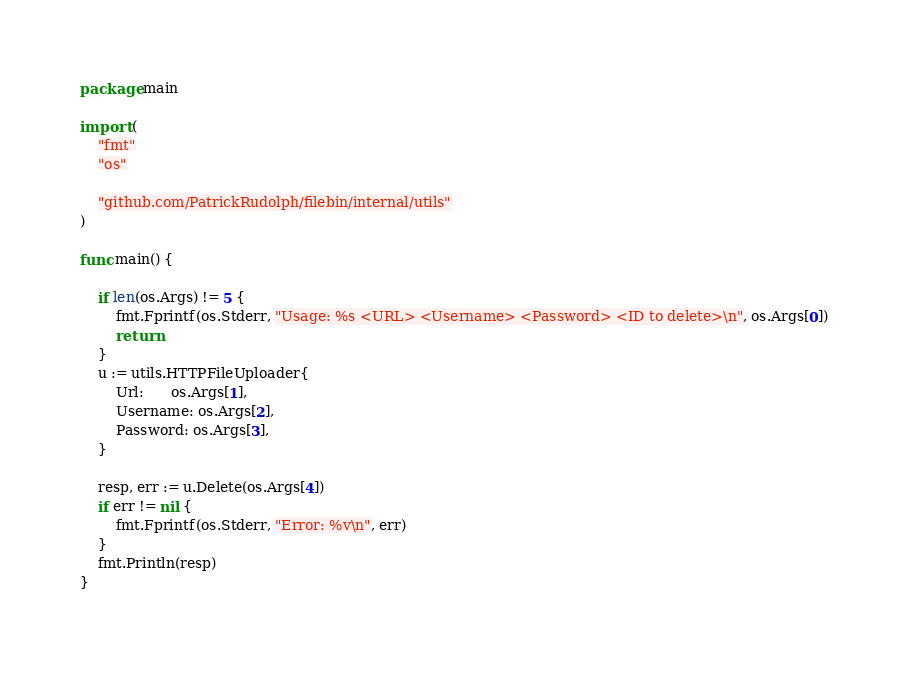Convert code to text. <code><loc_0><loc_0><loc_500><loc_500><_Go_>package main

import (
	"fmt"
	"os"

	"github.com/PatrickRudolph/filebin/internal/utils"
)

func main() {

	if len(os.Args) != 5 {
		fmt.Fprintf(os.Stderr, "Usage: %s <URL> <Username> <Password> <ID to delete>\n", os.Args[0])
		return
	}
	u := utils.HTTPFileUploader{
		Url:      os.Args[1],
		Username: os.Args[2],
		Password: os.Args[3],
	}

	resp, err := u.Delete(os.Args[4])
	if err != nil {
		fmt.Fprintf(os.Stderr, "Error: %v\n", err)
	}
	fmt.Println(resp)
}
</code> 